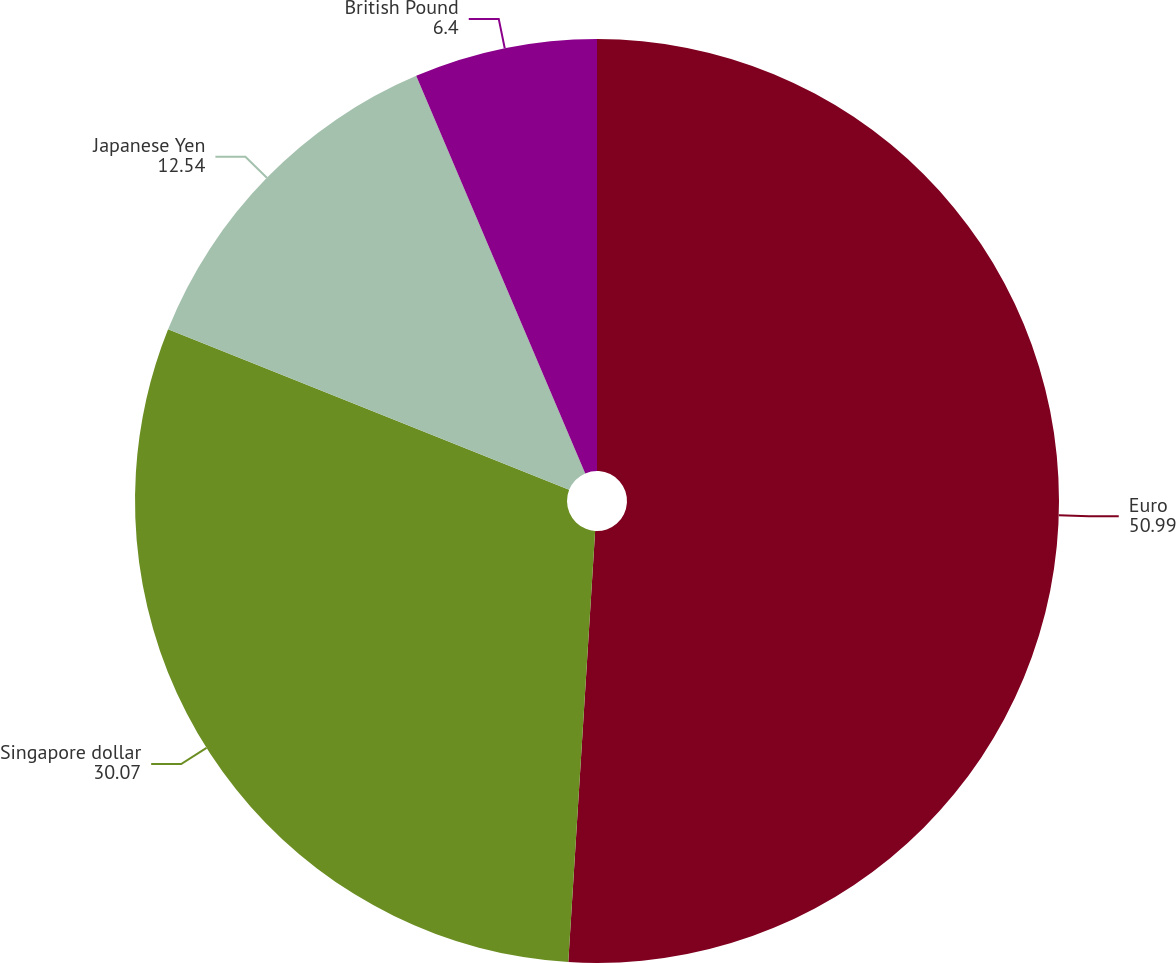Convert chart to OTSL. <chart><loc_0><loc_0><loc_500><loc_500><pie_chart><fcel>Euro<fcel>Singapore dollar<fcel>Japanese Yen<fcel>British Pound<nl><fcel>50.99%<fcel>30.07%<fcel>12.54%<fcel>6.4%<nl></chart> 